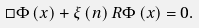<formula> <loc_0><loc_0><loc_500><loc_500>\square \Phi \left ( x \right ) + \xi \left ( n \right ) R \Phi \left ( x \right ) = 0 .</formula> 